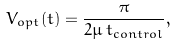<formula> <loc_0><loc_0><loc_500><loc_500>V _ { o p t } ( t ) = \frac { \pi } { 2 \mu \, t _ { c o n t r o l } } ,</formula> 